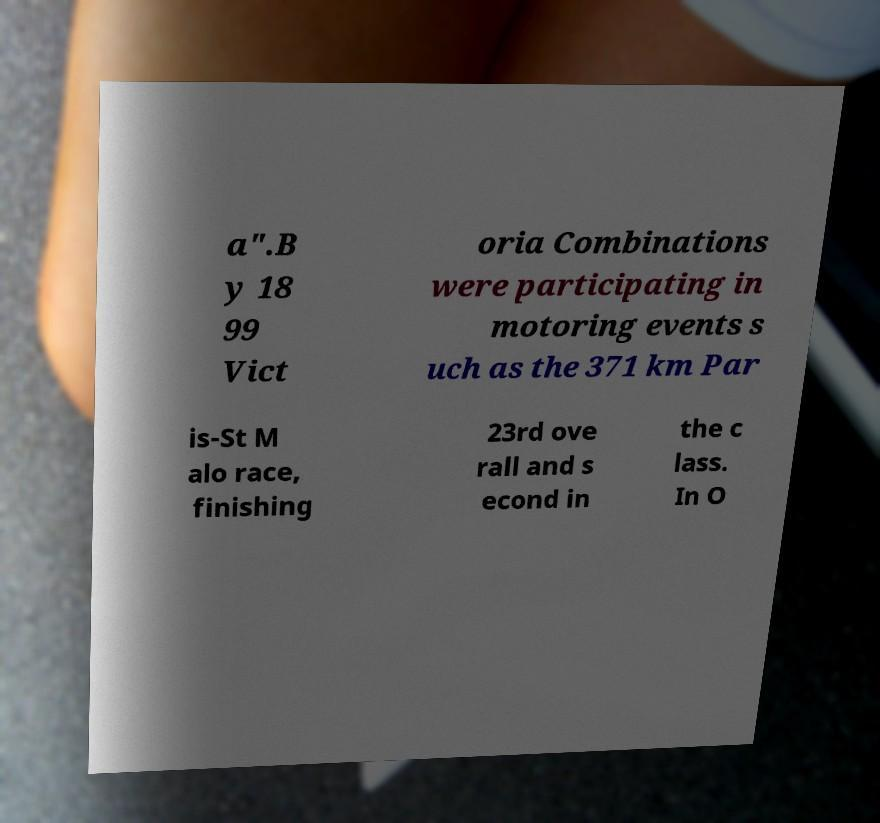I need the written content from this picture converted into text. Can you do that? a".B y 18 99 Vict oria Combinations were participating in motoring events s uch as the 371 km Par is-St M alo race, finishing 23rd ove rall and s econd in the c lass. In O 